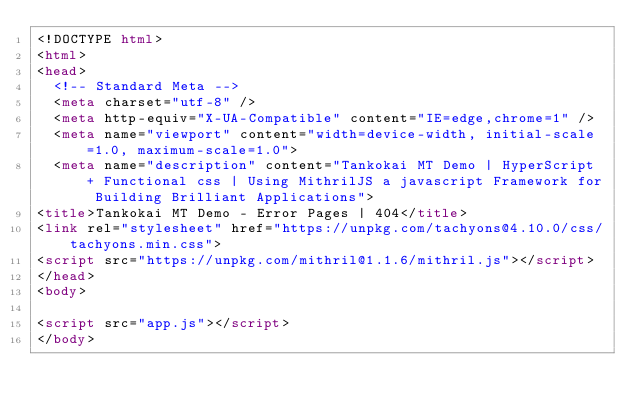<code> <loc_0><loc_0><loc_500><loc_500><_HTML_><!DOCTYPE html>
<html>
<head>
  <!-- Standard Meta -->
  <meta charset="utf-8" />
  <meta http-equiv="X-UA-Compatible" content="IE=edge,chrome=1" />
  <meta name="viewport" content="width=device-width, initial-scale=1.0, maximum-scale=1.0">
  <meta name="description" content="Tankokai MT Demo | HyperScript + Functional css | Using MithrilJS a javascript Framework for Building Brilliant Applications">
<title>Tankokai MT Demo - Error Pages | 404</title>
<link rel="stylesheet" href="https://unpkg.com/tachyons@4.10.0/css/tachyons.min.css">
<script src="https://unpkg.com/mithril@1.1.6/mithril.js"></script>
</head>
<body>

<script src="app.js"></script>
</body>
</code> 